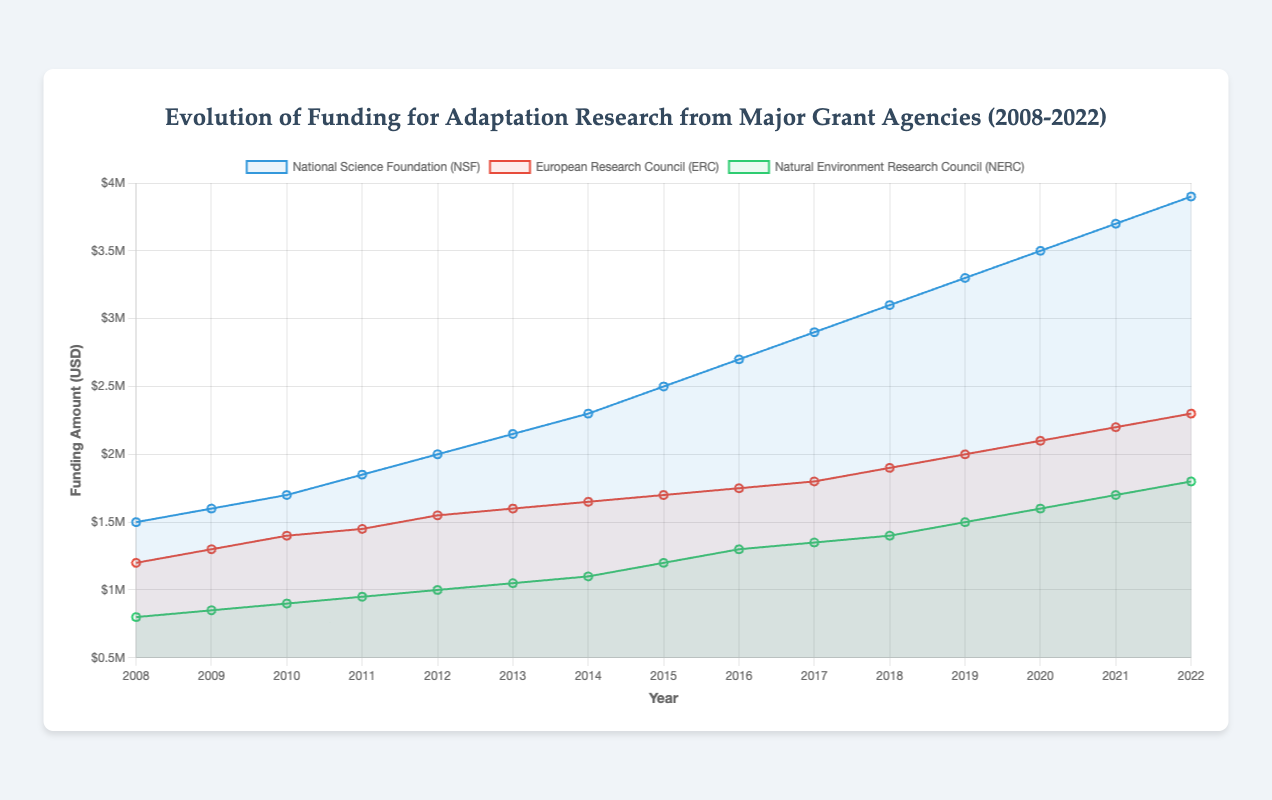Which grant agency had the highest funding in 2015? Look at the points on each line corresponding to the year 2015. The NSF line is the highest.
Answer: National Science Foundation (NSF) Between 2010 and 2014, which agency showed the greatest increase in funding? Compare the funding amounts for each agency from 2010 to 2014. NSF increased from 1,700,000 to 2,300,000, ERC from 1,400,000 to 1,650,000, and NERC from 900,000 to 1,100,000. The greatest increase is for NSF.
Answer: National Science Foundation (NSF) What was the total funding from ERC and NERC in 2012? Add the 2012 values for ERC (1,550,000) and NERC (1,000,000). 1,550,000 + 1,000,000 = 2,550,000.
Answer: 2,550,000 In which year did ERC funding surpass 2,000,000 for the first time? Trace the ERC line and find the year where it first exceeds 2,000,000. This occurs in 2019.
Answer: 2019 Which agency had a funding amount closest to 1,000,000 in 2014? Look at the values for each agency in 2014. NERC had a funding amount of 1,100,000, which is closest to 1,000,000.
Answer: Natural Environment Research Council (NERC) By how much did NSF funding increase from 2016 to 2020? Subtract the 2016 value for NSF (2,700,000) from the 2020 value (3,500,000). 3,500,000 - 2,700,000 = 800,000.
Answer: 800,000 Which agency consistently had the lowest funding from 2008 to 2022? Compare the lines for each agency across all years. NERC is always the lowest.
Answer: Natural Environment Research Council (NERC) Was there any year when all three agencies had the same funding amount? Compare the lines for all years. There is no year where all three values are equal.
Answer: No Calculate the average funding of NSF over the years 2008-2012. Sum the NSF values from 2008-2012 (1,500,000 + 1,600,000 + 1,700,000 + 1,850,000 + 2,000,000 = 8,650,000) and divide by 5. 8,650,000 / 5 = 1,730,000.
Answer: 1,730,000 Between 2010 and 2022, in how many years did NERC funding exceed 1,000,000? Review NERC funding from 2010 to 2022 and count the years above 1,000,000. These years are 2015-2022, totaling 8 years.
Answer: 8 years 